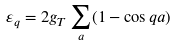<formula> <loc_0><loc_0><loc_500><loc_500>\varepsilon _ { q } = 2 g _ { T } \sum _ { a } ( 1 - \cos q a )</formula> 